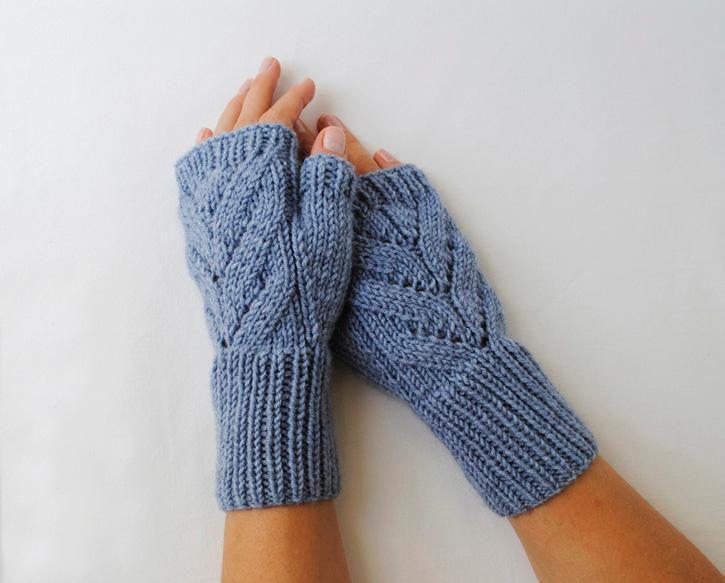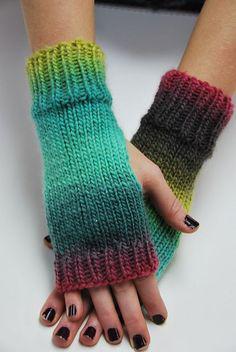The first image is the image on the left, the second image is the image on the right. Examine the images to the left and right. Is the description "In one of the images there is a single mitten worn on an empty hand." accurate? Answer yes or no. No. The first image is the image on the left, the second image is the image on the right. Given the left and right images, does the statement "An image includes a hand wearing a solid-blue fingerless mitten." hold true? Answer yes or no. Yes. 